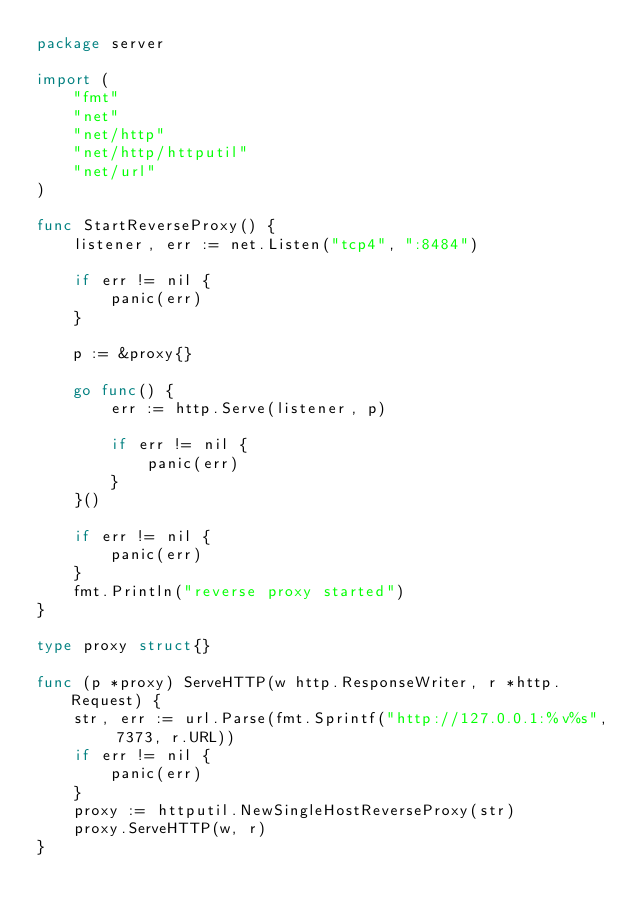Convert code to text. <code><loc_0><loc_0><loc_500><loc_500><_Go_>package server

import (
	"fmt"
	"net"
	"net/http"
	"net/http/httputil"
	"net/url"
)

func StartReverseProxy() {
	listener, err := net.Listen("tcp4", ":8484")

	if err != nil {
		panic(err)
	}

	p := &proxy{}

	go func() {
		err := http.Serve(listener, p)

		if err != nil {
			panic(err)
		}
	}()

	if err != nil {
		panic(err)
	}
	fmt.Println("reverse proxy started")
}

type proxy struct{}

func (p *proxy) ServeHTTP(w http.ResponseWriter, r *http.Request) {
	str, err := url.Parse(fmt.Sprintf("http://127.0.0.1:%v%s", 7373, r.URL))
	if err != nil {
		panic(err)
	}
	proxy := httputil.NewSingleHostReverseProxy(str)
	proxy.ServeHTTP(w, r)
}
</code> 